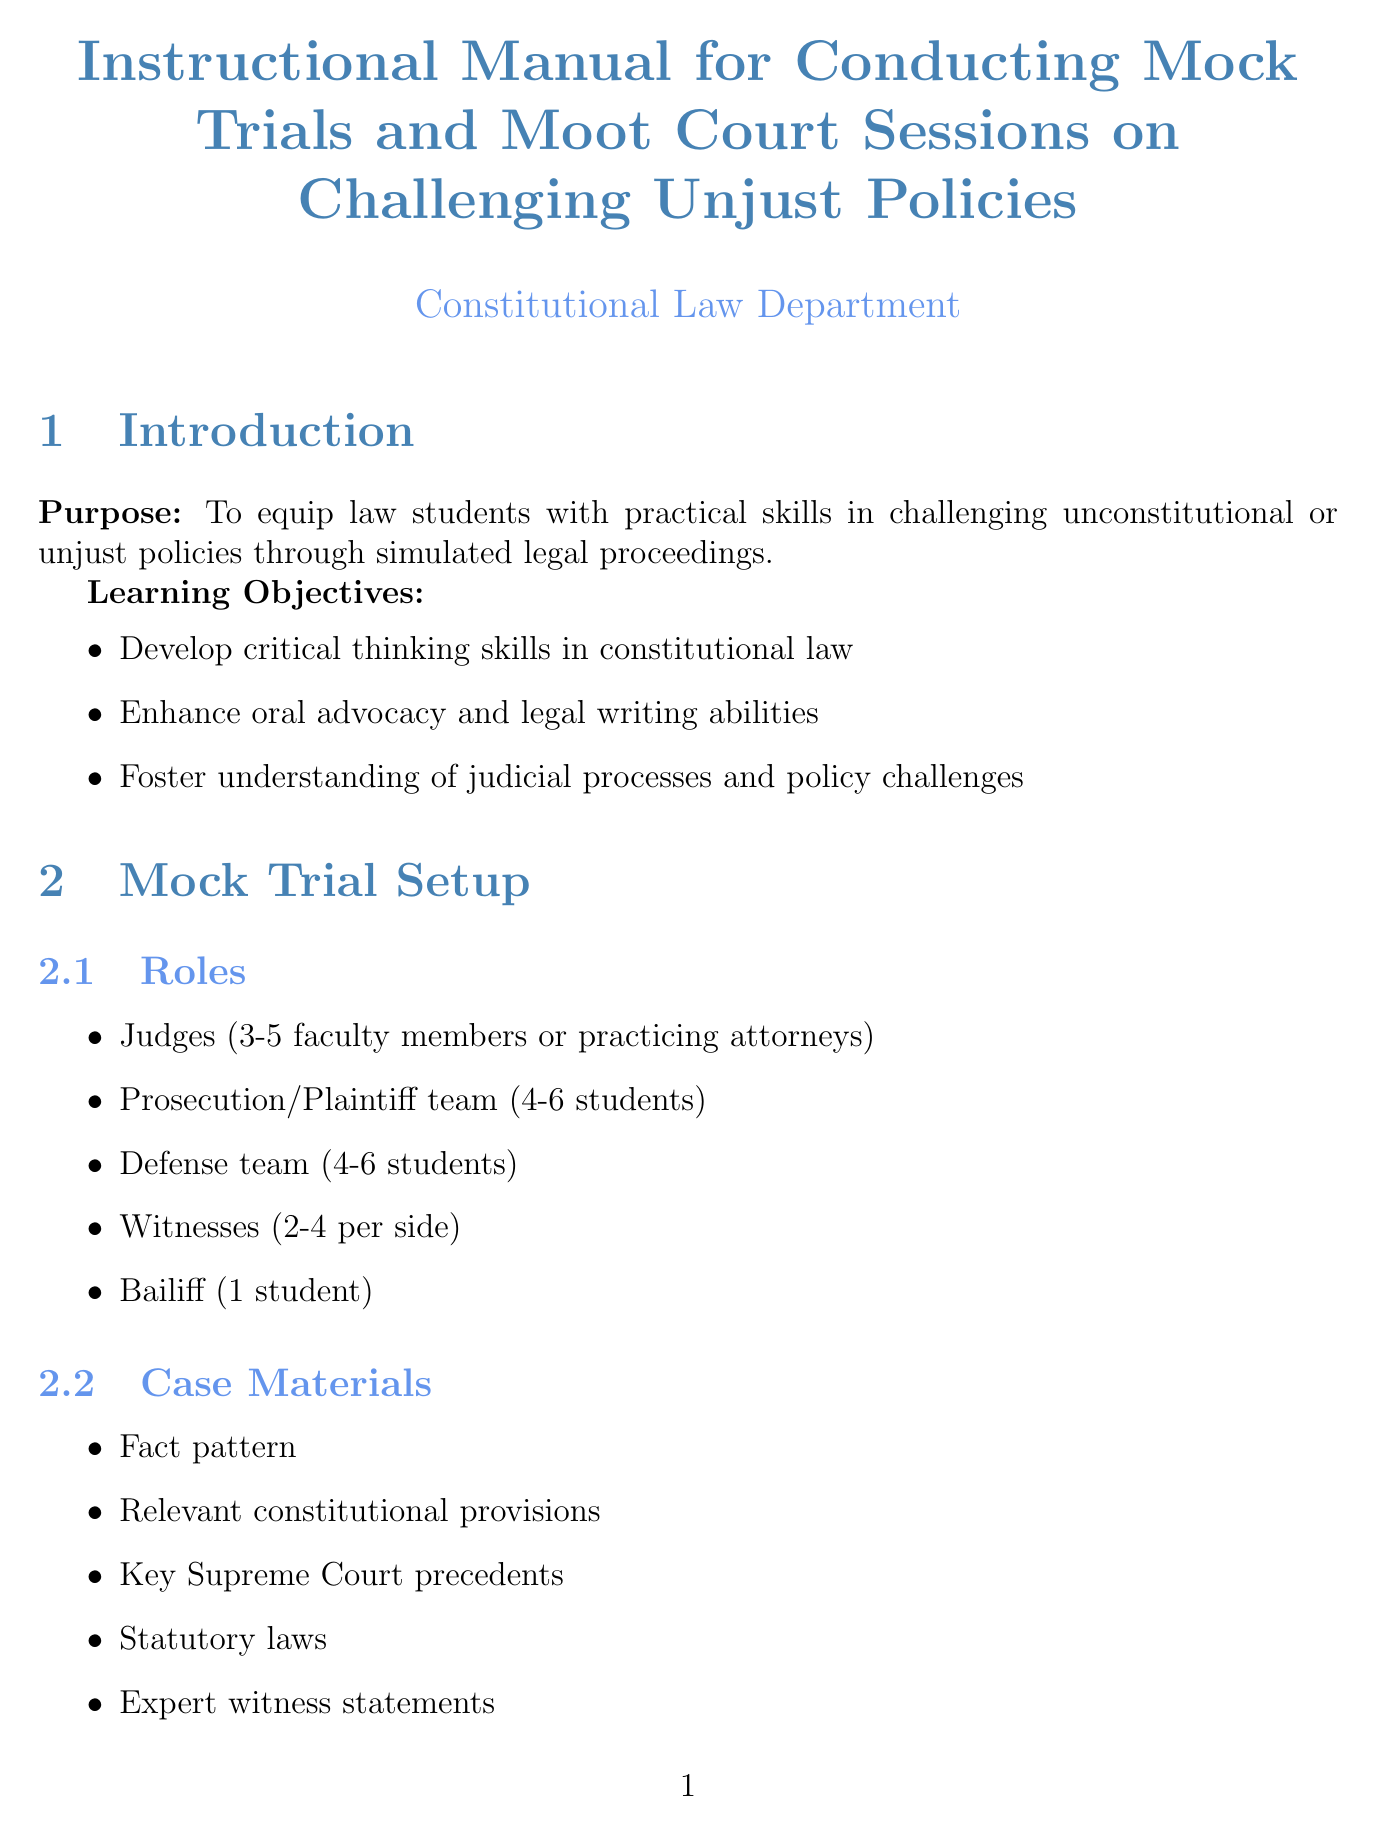What is the purpose of the manual? The purpose is stated in the introduction, aiming to equip law students with practical skills in challenging unconstitutional or unjust policies.
Answer: To equip law students with practical skills in challenging unconstitutional or unjust policies How many judges are on the mock trial panel? The setup specifies that there should be 3 to 5 faculty members or practicing attorneys serving as judges.
Answer: 3-5 What is one of the sample cases related to same-sex marriage? The document lists "Obergefell v. Hodges" as a sample case concerning same-sex marriage.
Answer: Obergefell v. Hodges What is included in the preparation guidelines for brief writing? The document outlines that the structure should consist of Introduction, Statement of Facts, Argument, and Conclusion.
Answer: Structure (Introduction, Statement of Facts, Argument, Conclusion) What is the debriefing purpose after the sessions? The manual states that debriefing aims to discuss strengths and areas for improvement post-session.
Answer: Discuss strengths and areas for improvement Which legal database is mentioned as a resource? The resources section lists multiple legal databases, including Westlaw.
Answer: Westlaw How many students are typically in the petitioner team for the moot court setup? The setup indicates that the petitioner team should consist of 2 to 3 students.
Answer: 2-3 What is a key evaluation criterion listed in the manual? The document outlines several evaluation criteria, one of which is the quality of legal analysis.
Answer: Quality of legal analysis 